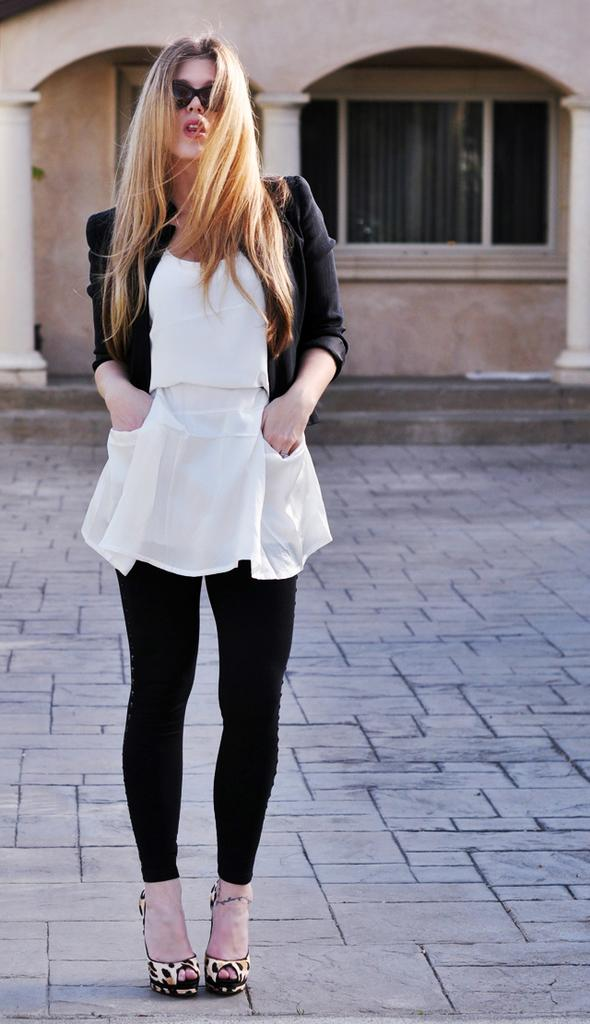Who is present in the image? There is a woman in the image. What is the woman's position in the image? The woman is standing on the floor. What can be seen in the background of the image? There are windows and walls in the background of the image. What type of cake can be seen in the yard in the image? There is no cake or yard present in the image; it features a woman standing on the floor with windows and walls in the background. 